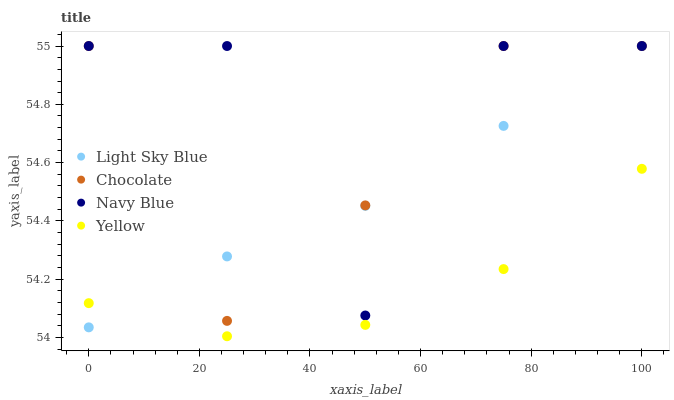Does Yellow have the minimum area under the curve?
Answer yes or no. Yes. Does Navy Blue have the maximum area under the curve?
Answer yes or no. Yes. Does Light Sky Blue have the minimum area under the curve?
Answer yes or no. No. Does Light Sky Blue have the maximum area under the curve?
Answer yes or no. No. Is Light Sky Blue the smoothest?
Answer yes or no. Yes. Is Navy Blue the roughest?
Answer yes or no. Yes. Is Yellow the smoothest?
Answer yes or no. No. Is Yellow the roughest?
Answer yes or no. No. Does Yellow have the lowest value?
Answer yes or no. Yes. Does Light Sky Blue have the lowest value?
Answer yes or no. No. Does Chocolate have the highest value?
Answer yes or no. Yes. Does Yellow have the highest value?
Answer yes or no. No. Is Yellow less than Chocolate?
Answer yes or no. Yes. Is Chocolate greater than Yellow?
Answer yes or no. Yes. Does Light Sky Blue intersect Yellow?
Answer yes or no. Yes. Is Light Sky Blue less than Yellow?
Answer yes or no. No. Is Light Sky Blue greater than Yellow?
Answer yes or no. No. Does Yellow intersect Chocolate?
Answer yes or no. No. 